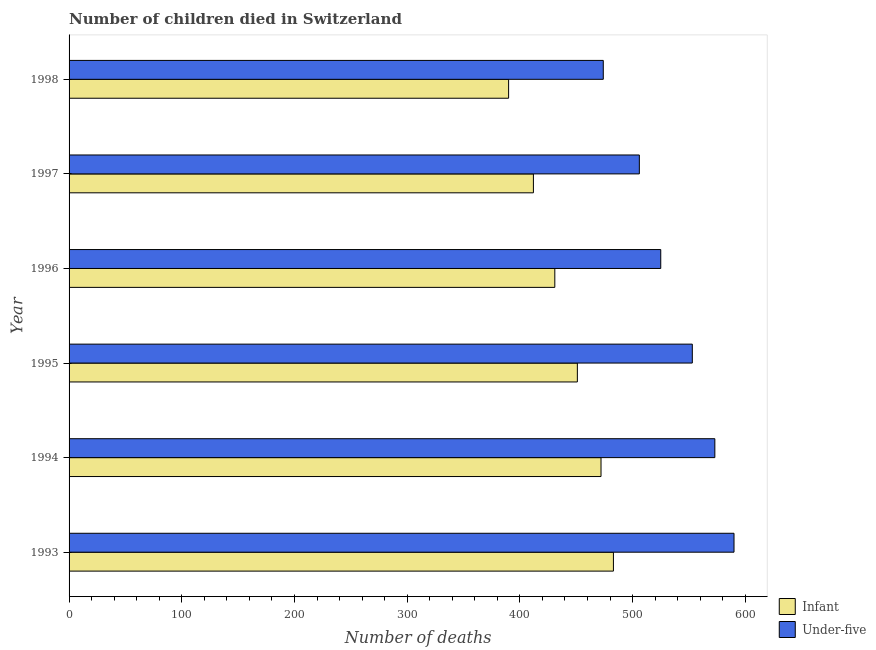How many different coloured bars are there?
Offer a terse response. 2. How many groups of bars are there?
Your answer should be compact. 6. Are the number of bars on each tick of the Y-axis equal?
Ensure brevity in your answer.  Yes. What is the label of the 2nd group of bars from the top?
Your answer should be compact. 1997. What is the number of infant deaths in 1996?
Your answer should be very brief. 431. Across all years, what is the maximum number of under-five deaths?
Give a very brief answer. 590. Across all years, what is the minimum number of infant deaths?
Provide a succinct answer. 390. In which year was the number of under-five deaths minimum?
Offer a terse response. 1998. What is the total number of under-five deaths in the graph?
Offer a very short reply. 3221. What is the difference between the number of under-five deaths in 1996 and that in 1997?
Offer a terse response. 19. What is the difference between the number of infant deaths in 1998 and the number of under-five deaths in 1996?
Your response must be concise. -135. What is the average number of infant deaths per year?
Provide a short and direct response. 439.83. In the year 1998, what is the difference between the number of under-five deaths and number of infant deaths?
Provide a succinct answer. 84. What is the ratio of the number of infant deaths in 1994 to that in 1997?
Offer a very short reply. 1.15. What is the difference between the highest and the second highest number of under-five deaths?
Give a very brief answer. 17. What is the difference between the highest and the lowest number of infant deaths?
Provide a succinct answer. 93. Is the sum of the number of under-five deaths in 1997 and 1998 greater than the maximum number of infant deaths across all years?
Provide a succinct answer. Yes. What does the 1st bar from the top in 1998 represents?
Keep it short and to the point. Under-five. What does the 2nd bar from the bottom in 1995 represents?
Give a very brief answer. Under-five. Are all the bars in the graph horizontal?
Provide a short and direct response. Yes. What is the difference between two consecutive major ticks on the X-axis?
Keep it short and to the point. 100. Does the graph contain grids?
Keep it short and to the point. No. How many legend labels are there?
Make the answer very short. 2. What is the title of the graph?
Provide a short and direct response. Number of children died in Switzerland. What is the label or title of the X-axis?
Ensure brevity in your answer.  Number of deaths. What is the Number of deaths in Infant in 1993?
Make the answer very short. 483. What is the Number of deaths of Under-five in 1993?
Your answer should be compact. 590. What is the Number of deaths in Infant in 1994?
Provide a short and direct response. 472. What is the Number of deaths of Under-five in 1994?
Keep it short and to the point. 573. What is the Number of deaths of Infant in 1995?
Offer a terse response. 451. What is the Number of deaths in Under-five in 1995?
Offer a terse response. 553. What is the Number of deaths of Infant in 1996?
Offer a very short reply. 431. What is the Number of deaths in Under-five in 1996?
Keep it short and to the point. 525. What is the Number of deaths in Infant in 1997?
Your answer should be compact. 412. What is the Number of deaths of Under-five in 1997?
Offer a terse response. 506. What is the Number of deaths in Infant in 1998?
Make the answer very short. 390. What is the Number of deaths in Under-five in 1998?
Make the answer very short. 474. Across all years, what is the maximum Number of deaths in Infant?
Your answer should be compact. 483. Across all years, what is the maximum Number of deaths of Under-five?
Provide a succinct answer. 590. Across all years, what is the minimum Number of deaths of Infant?
Keep it short and to the point. 390. Across all years, what is the minimum Number of deaths of Under-five?
Ensure brevity in your answer.  474. What is the total Number of deaths in Infant in the graph?
Offer a very short reply. 2639. What is the total Number of deaths of Under-five in the graph?
Keep it short and to the point. 3221. What is the difference between the Number of deaths of Under-five in 1993 and that in 1994?
Your answer should be compact. 17. What is the difference between the Number of deaths of Infant in 1993 and that in 1995?
Ensure brevity in your answer.  32. What is the difference between the Number of deaths of Infant in 1993 and that in 1996?
Ensure brevity in your answer.  52. What is the difference between the Number of deaths of Infant in 1993 and that in 1998?
Offer a very short reply. 93. What is the difference between the Number of deaths of Under-five in 1993 and that in 1998?
Offer a terse response. 116. What is the difference between the Number of deaths in Infant in 1994 and that in 1995?
Offer a very short reply. 21. What is the difference between the Number of deaths in Infant in 1994 and that in 1996?
Make the answer very short. 41. What is the difference between the Number of deaths of Under-five in 1994 and that in 1996?
Keep it short and to the point. 48. What is the difference between the Number of deaths in Infant in 1994 and that in 1997?
Your response must be concise. 60. What is the difference between the Number of deaths in Infant in 1994 and that in 1998?
Provide a short and direct response. 82. What is the difference between the Number of deaths of Under-five in 1995 and that in 1996?
Your answer should be compact. 28. What is the difference between the Number of deaths of Infant in 1995 and that in 1998?
Provide a short and direct response. 61. What is the difference between the Number of deaths in Under-five in 1995 and that in 1998?
Make the answer very short. 79. What is the difference between the Number of deaths of Under-five in 1996 and that in 1997?
Your answer should be very brief. 19. What is the difference between the Number of deaths of Infant in 1993 and the Number of deaths of Under-five in 1994?
Ensure brevity in your answer.  -90. What is the difference between the Number of deaths of Infant in 1993 and the Number of deaths of Under-five in 1995?
Offer a terse response. -70. What is the difference between the Number of deaths of Infant in 1993 and the Number of deaths of Under-five in 1996?
Your answer should be very brief. -42. What is the difference between the Number of deaths of Infant in 1994 and the Number of deaths of Under-five in 1995?
Offer a very short reply. -81. What is the difference between the Number of deaths of Infant in 1994 and the Number of deaths of Under-five in 1996?
Your answer should be very brief. -53. What is the difference between the Number of deaths in Infant in 1994 and the Number of deaths in Under-five in 1997?
Keep it short and to the point. -34. What is the difference between the Number of deaths in Infant in 1995 and the Number of deaths in Under-five in 1996?
Your response must be concise. -74. What is the difference between the Number of deaths in Infant in 1995 and the Number of deaths in Under-five in 1997?
Provide a succinct answer. -55. What is the difference between the Number of deaths in Infant in 1995 and the Number of deaths in Under-five in 1998?
Your response must be concise. -23. What is the difference between the Number of deaths in Infant in 1996 and the Number of deaths in Under-five in 1997?
Ensure brevity in your answer.  -75. What is the difference between the Number of deaths of Infant in 1996 and the Number of deaths of Under-five in 1998?
Ensure brevity in your answer.  -43. What is the difference between the Number of deaths in Infant in 1997 and the Number of deaths in Under-five in 1998?
Provide a succinct answer. -62. What is the average Number of deaths of Infant per year?
Your response must be concise. 439.83. What is the average Number of deaths of Under-five per year?
Make the answer very short. 536.83. In the year 1993, what is the difference between the Number of deaths in Infant and Number of deaths in Under-five?
Offer a terse response. -107. In the year 1994, what is the difference between the Number of deaths of Infant and Number of deaths of Under-five?
Give a very brief answer. -101. In the year 1995, what is the difference between the Number of deaths in Infant and Number of deaths in Under-five?
Make the answer very short. -102. In the year 1996, what is the difference between the Number of deaths in Infant and Number of deaths in Under-five?
Offer a terse response. -94. In the year 1997, what is the difference between the Number of deaths of Infant and Number of deaths of Under-five?
Your answer should be very brief. -94. In the year 1998, what is the difference between the Number of deaths of Infant and Number of deaths of Under-five?
Offer a very short reply. -84. What is the ratio of the Number of deaths of Infant in 1993 to that in 1994?
Your response must be concise. 1.02. What is the ratio of the Number of deaths in Under-five in 1993 to that in 1994?
Ensure brevity in your answer.  1.03. What is the ratio of the Number of deaths of Infant in 1993 to that in 1995?
Your response must be concise. 1.07. What is the ratio of the Number of deaths in Under-five in 1993 to that in 1995?
Ensure brevity in your answer.  1.07. What is the ratio of the Number of deaths in Infant in 1993 to that in 1996?
Offer a very short reply. 1.12. What is the ratio of the Number of deaths in Under-five in 1993 to that in 1996?
Provide a succinct answer. 1.12. What is the ratio of the Number of deaths of Infant in 1993 to that in 1997?
Offer a terse response. 1.17. What is the ratio of the Number of deaths in Under-five in 1993 to that in 1997?
Your response must be concise. 1.17. What is the ratio of the Number of deaths in Infant in 1993 to that in 1998?
Offer a terse response. 1.24. What is the ratio of the Number of deaths in Under-five in 1993 to that in 1998?
Provide a succinct answer. 1.24. What is the ratio of the Number of deaths in Infant in 1994 to that in 1995?
Offer a terse response. 1.05. What is the ratio of the Number of deaths in Under-five in 1994 to that in 1995?
Provide a succinct answer. 1.04. What is the ratio of the Number of deaths in Infant in 1994 to that in 1996?
Keep it short and to the point. 1.1. What is the ratio of the Number of deaths of Under-five in 1994 to that in 1996?
Make the answer very short. 1.09. What is the ratio of the Number of deaths in Infant in 1994 to that in 1997?
Offer a terse response. 1.15. What is the ratio of the Number of deaths in Under-five in 1994 to that in 1997?
Make the answer very short. 1.13. What is the ratio of the Number of deaths in Infant in 1994 to that in 1998?
Your answer should be compact. 1.21. What is the ratio of the Number of deaths of Under-five in 1994 to that in 1998?
Provide a short and direct response. 1.21. What is the ratio of the Number of deaths of Infant in 1995 to that in 1996?
Make the answer very short. 1.05. What is the ratio of the Number of deaths of Under-five in 1995 to that in 1996?
Ensure brevity in your answer.  1.05. What is the ratio of the Number of deaths in Infant in 1995 to that in 1997?
Ensure brevity in your answer.  1.09. What is the ratio of the Number of deaths in Under-five in 1995 to that in 1997?
Offer a very short reply. 1.09. What is the ratio of the Number of deaths of Infant in 1995 to that in 1998?
Your answer should be compact. 1.16. What is the ratio of the Number of deaths of Under-five in 1995 to that in 1998?
Make the answer very short. 1.17. What is the ratio of the Number of deaths of Infant in 1996 to that in 1997?
Offer a very short reply. 1.05. What is the ratio of the Number of deaths in Under-five in 1996 to that in 1997?
Offer a very short reply. 1.04. What is the ratio of the Number of deaths of Infant in 1996 to that in 1998?
Ensure brevity in your answer.  1.11. What is the ratio of the Number of deaths in Under-five in 1996 to that in 1998?
Give a very brief answer. 1.11. What is the ratio of the Number of deaths of Infant in 1997 to that in 1998?
Make the answer very short. 1.06. What is the ratio of the Number of deaths of Under-five in 1997 to that in 1998?
Give a very brief answer. 1.07. What is the difference between the highest and the lowest Number of deaths in Infant?
Your response must be concise. 93. What is the difference between the highest and the lowest Number of deaths in Under-five?
Keep it short and to the point. 116. 